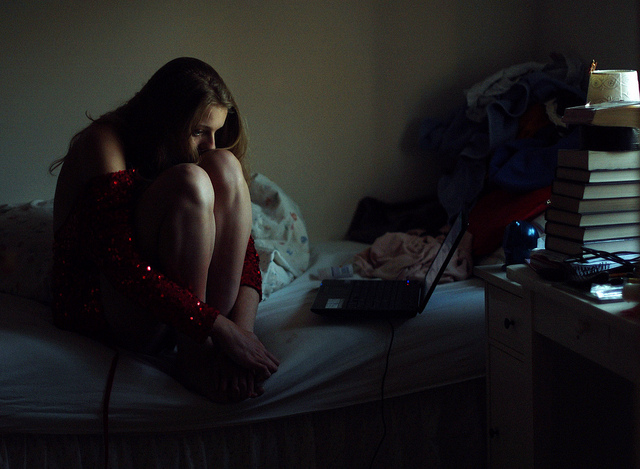<image>How many white items are in the room? It is unknown how many white items are in the room. How many white items are in the room? I am not sure how many white items are in the room. It can be seen as 4, 1, 2, 3, 11 or 5. 